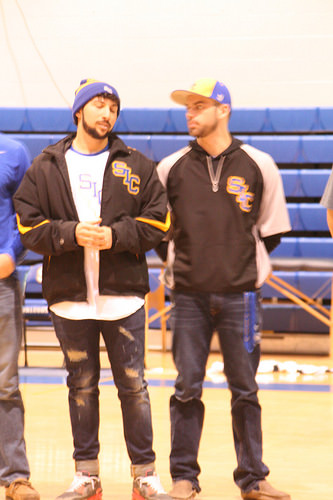<image>
Is the jacket on the man? No. The jacket is not positioned on the man. They may be near each other, but the jacket is not supported by or resting on top of the man. 